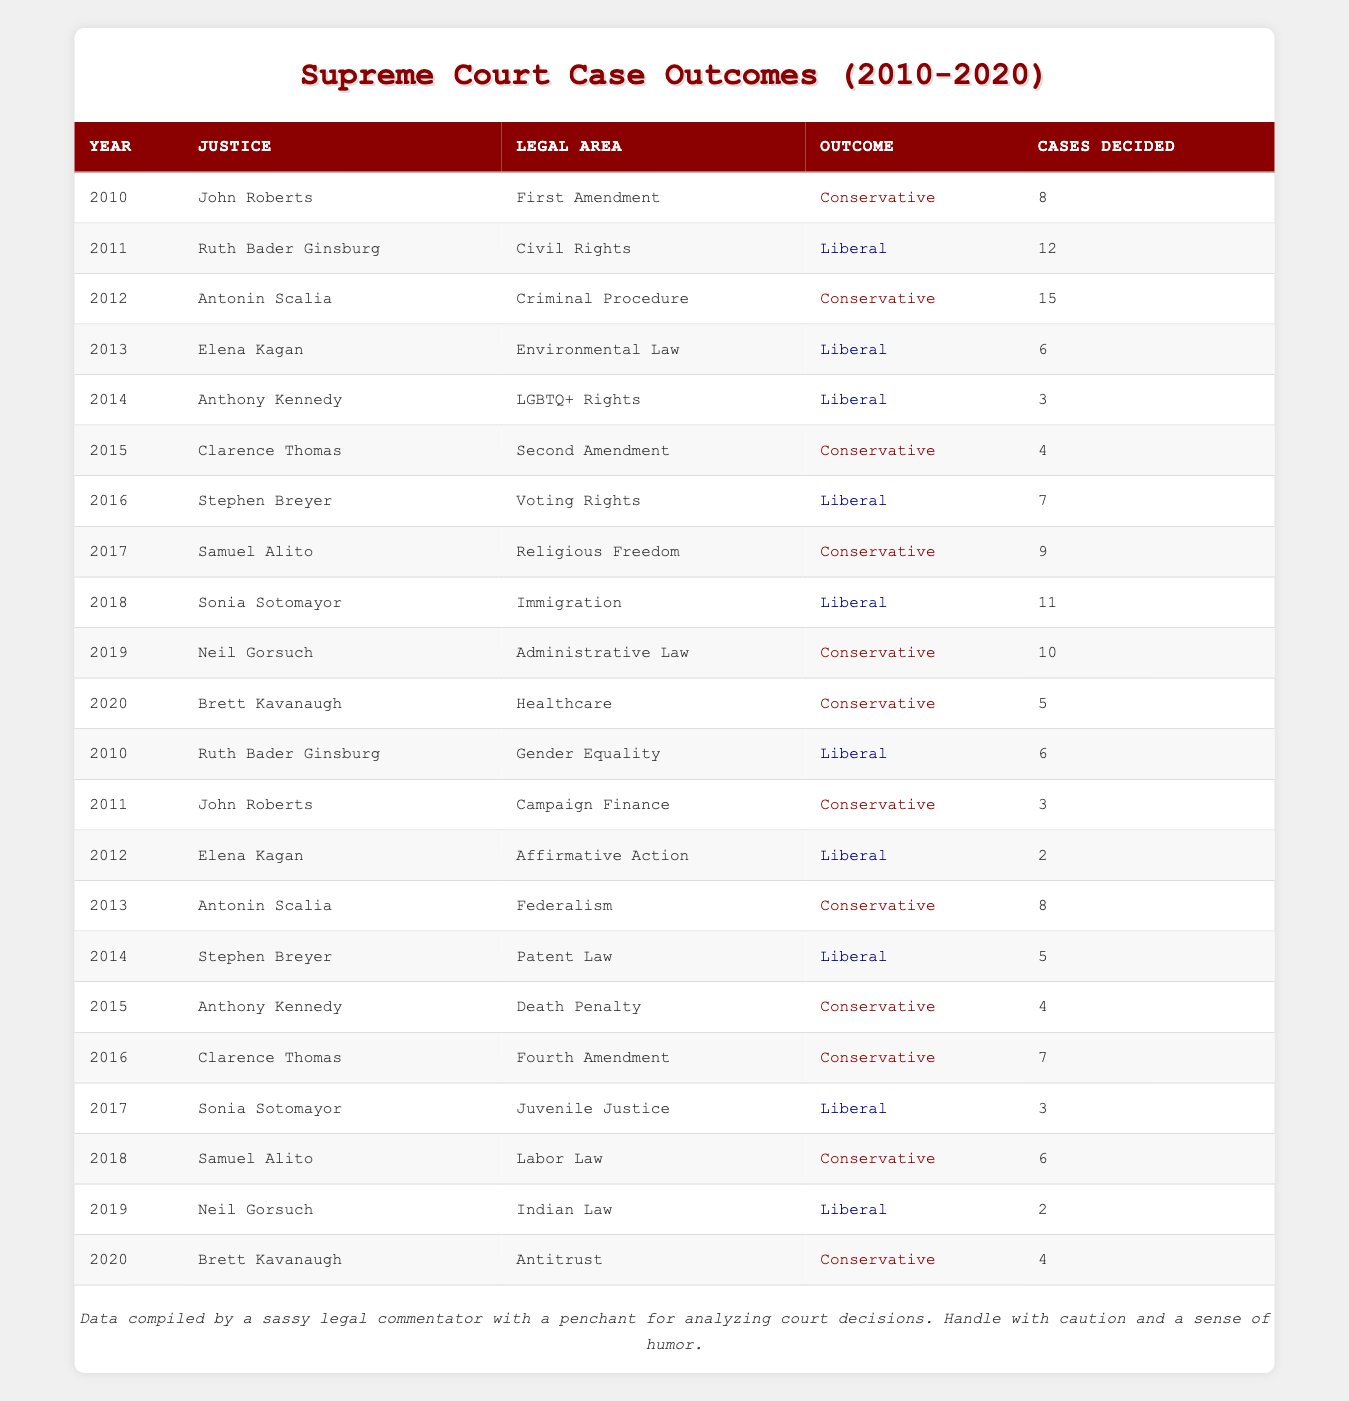What is the total number of cases decided by Ruth Bader Ginsburg? To find the total, we look for all entries for Ruth Bader Ginsburg in the table, which are for the years 2011 (12 cases) and 2010 (6 cases). Adding these gives us 12 + 6 = 18 cases.
Answer: 18 Which legal area did John Roberts have the most cases decided in? John Roberts had cases in the First Amendment (8 cases) in 2010 and Campaign Finance (3 cases) in 2011. The First Amendment has the higher number, so that is the legal area with the most cases decided by him.
Answer: First Amendment Did Ruth Bader Ginsburg ever have a conservative outcome during these years? All her outcomes listed in the table are Liberal (2010 and 2011), indicating she did not have any conservative outcomes during the specified years.
Answer: No How many cases did Anthony Kennedy decide in the area of LGBTQ+ Rights? Anthony Kennedy decided 3 cases in the area of LGBTQ+ Rights in 2014, as stated directly in the table.
Answer: 3 What is the average number of cases decided by the justices in Liberal outcomes? Summing up the cases decided by justices with Liberal outcomes: 12 (Ruth Bader Ginsburg, 2011) + 6 (Elena Kagan, 2013) + 3 (Anthony Kennedy, 2014) + 7 (Stephen Breyer, 2016) + 11 (Sonia Sotomayor, 2018) + 2 (Neil Gorsuch, 2019) + 6 (Ruth Bader Ginsburg, 2010) + 2 (Elena Kagan, 2012) + 5 (Stephen Breyer, 2014) + 3 (Sonia Sotomayor, 2017) = 55 cases. There are a total of 9 cases with Liberal outcomes, so the average is 55/9 ≈ 6.11.
Answer: Approximately 6.11 Which justice had the most cases decided overall and how many? To determine this, we check each justice's cases decided: John Roberts (11), Ruth Bader Ginsburg (18), Antonin Scalia (23), Elena Kagan (8), Anthony Kennedy (7), Clarence Thomas (11), Stephen Breyer (12), Samuel Alito (10), Sonia Sotomayor (14), Neil Gorsuch (12), and Brett Kavanaugh (9). Antonin Scalia had the most with 23 cases decided in total.
Answer: Antonin Scalia, 23 